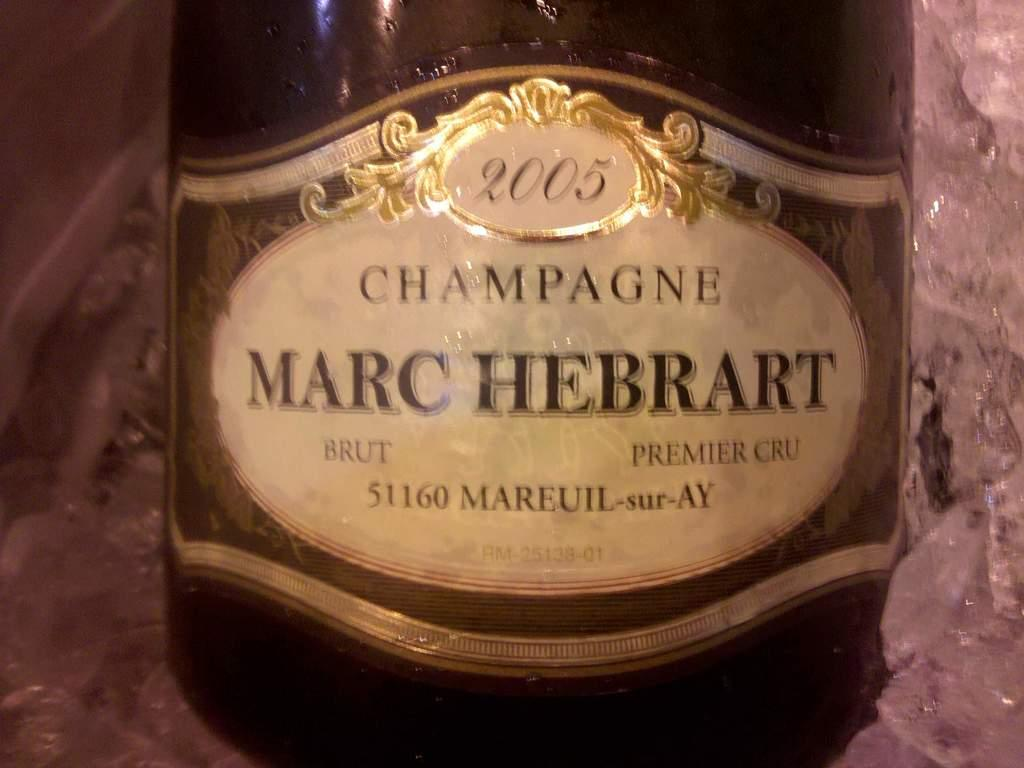What can you describe the object that is visible in the image? There is a bottle in the image. What can be found on the bottle? The bottle has text on it. What else is present in the image besides the bottle? There is a tray in the image. What is the tray used for in the image? The tray contains ice. Are there any cherries growing on the land in the image? There is no land or cherries present in the image; it only features a bottle and a tray with ice. 